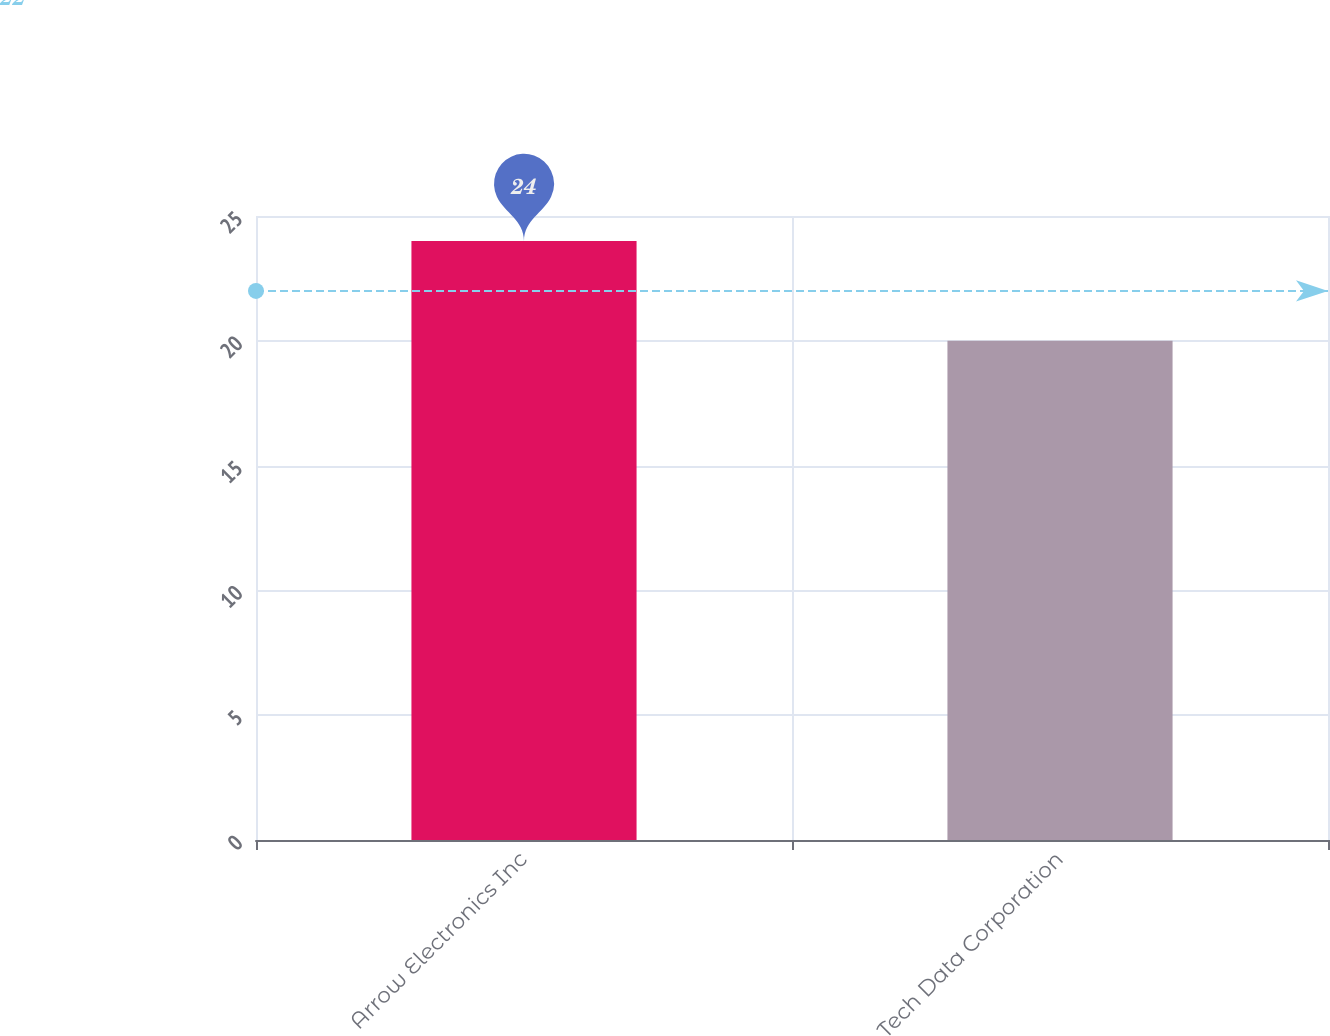Convert chart to OTSL. <chart><loc_0><loc_0><loc_500><loc_500><bar_chart><fcel>Arrow Electronics Inc<fcel>Tech Data Corporation<nl><fcel>24<fcel>20<nl></chart> 